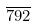<formula> <loc_0><loc_0><loc_500><loc_500>\overline { 7 9 2 }</formula> 